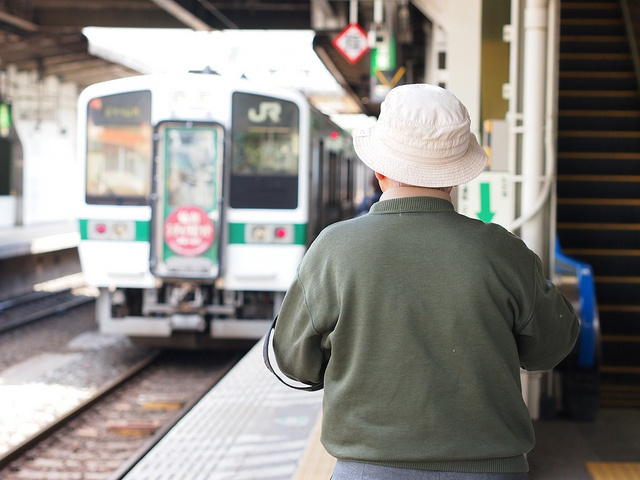Describe the objects in this image and their specific colors. I can see people in black, gray, white, and darkgray tones and train in black, white, darkgray, and gray tones in this image. 